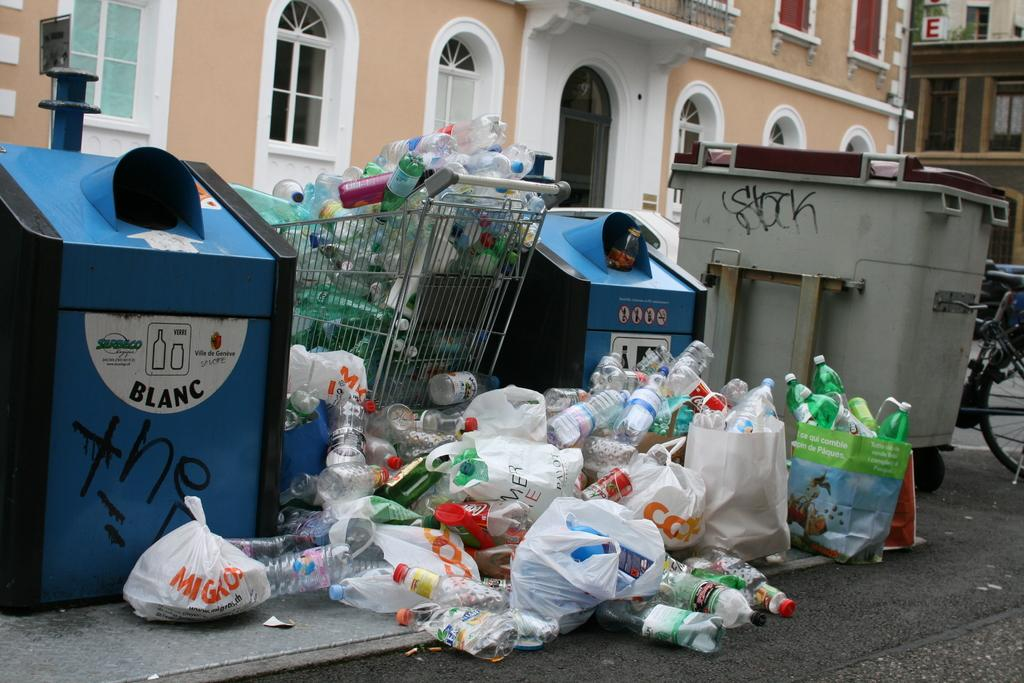<image>
Give a short and clear explanation of the subsequent image. the word blanc is on a blue trash can 